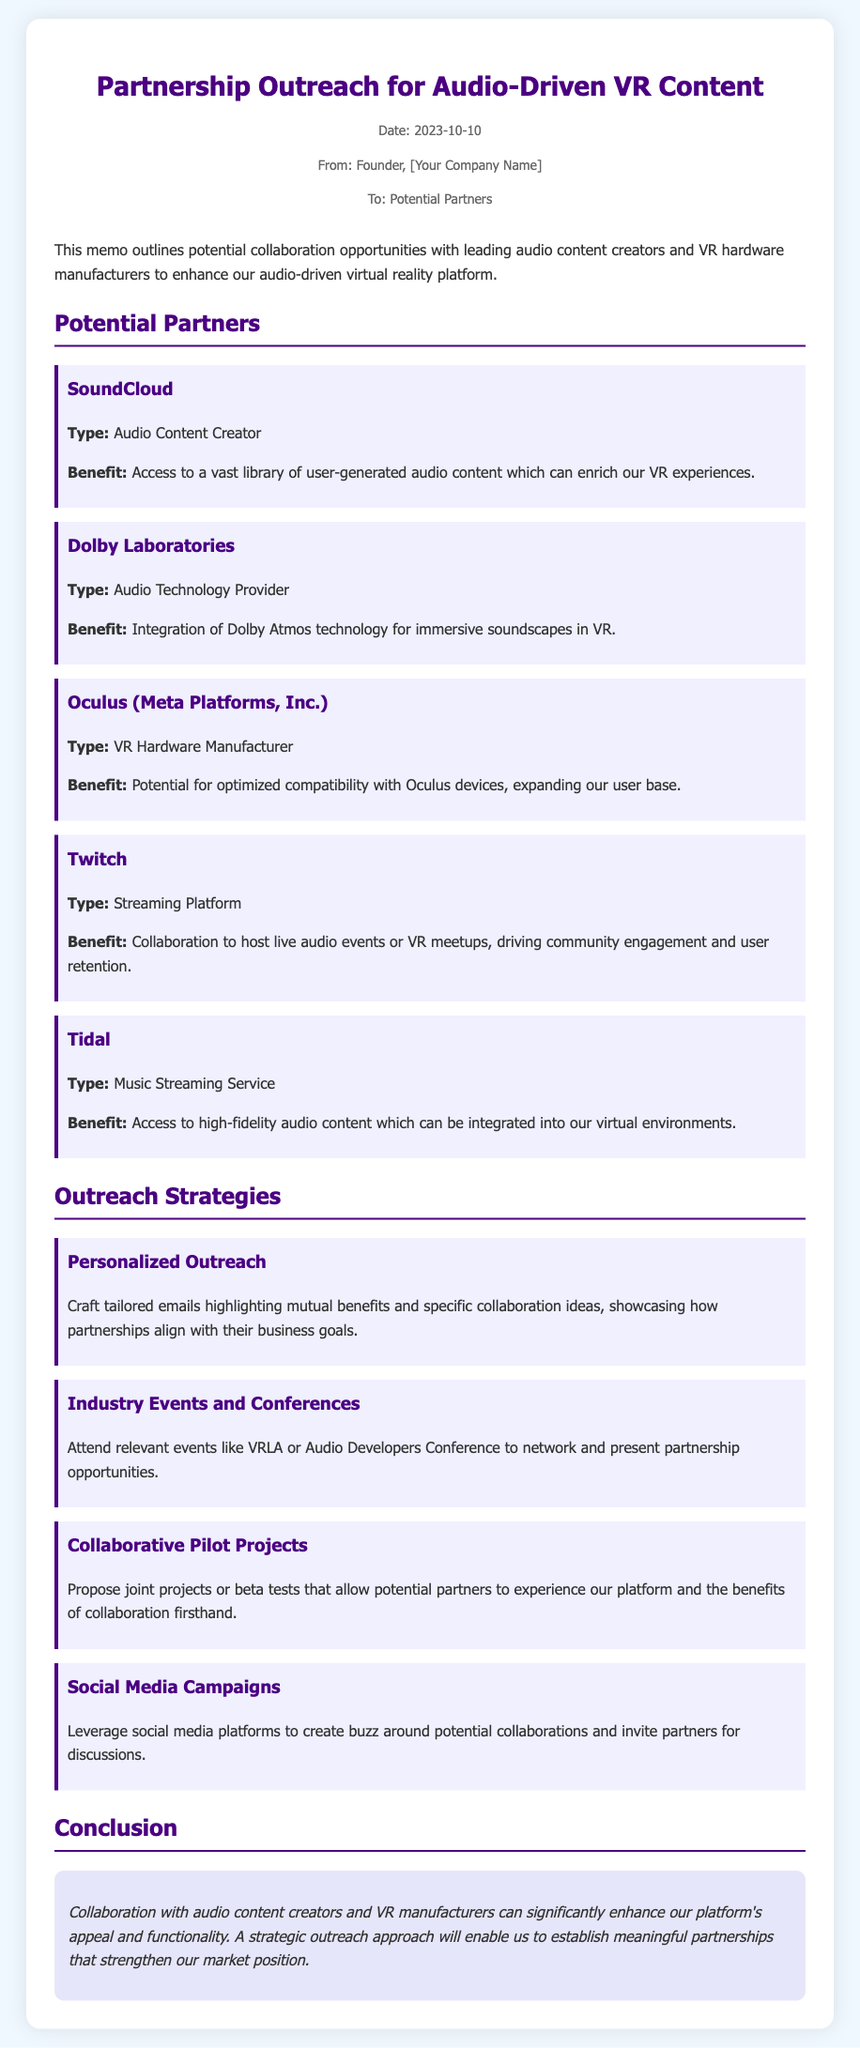name one audio content creator listed as a potential partner. One audio content creator listed in the memo is SoundCloud.
Answer: SoundCloud what technology does Dolby Laboratories provide? The memo mentions that Dolby Laboratories provides Dolby Atmos technology.
Answer: Dolby Atmos which VR hardware manufacturer is mentioned? The VR hardware manufacturer mentioned in the memo is Oculus (Meta Platforms, Inc.).
Answer: Oculus (Meta Platforms, Inc.) what is one benefit of collaborating with Tidal? The benefit of collaborating with Tidal is access to high-fidelity audio content.
Answer: Access to high-fidelity audio content what is one strategy for outreach mentioned in the memo? One outreach strategy mentioned is Personalized Outreach.
Answer: Personalized Outreach which event is recommended for networking? The event recommended for networking is VRLA.
Answer: VRLA what is the concluding thought regarding collaboration? The concluding thought emphasizes that collaboration can significantly enhance the platform's appeal and functionality.
Answer: Enhance the platform's appeal and functionality 